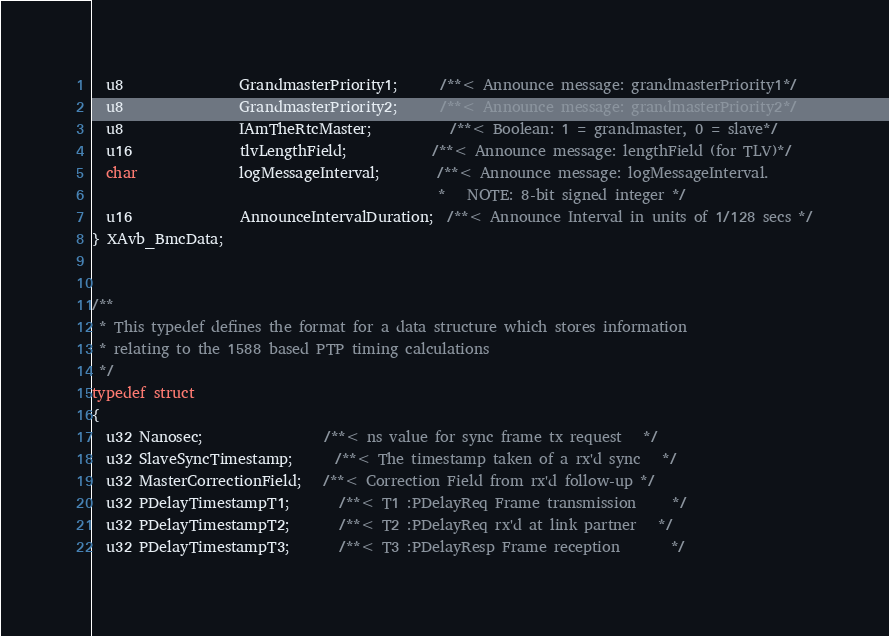Convert code to text. <code><loc_0><loc_0><loc_500><loc_500><_C_>  u8                GrandmasterPriority1;      /**< Announce message: grandmasterPriority1*/
  u8                GrandmasterPriority2;      /**< Announce message: grandmasterPriority2*/
  u8                IAmTheRtcMaster;           /**< Boolean: 1 = grandmaster, 0 = slave*/
  u16               tlvLengthField;            /**< Announce message: lengthField (for TLV)*/
  char              logMessageInterval;        /**< Announce message: logMessageInterval.
                                                *   NOTE: 8-bit signed integer */
  u16               AnnounceIntervalDuration;  /**< Announce Interval in units of 1/128 secs */
} XAvb_BmcData;


/**
 * This typedef defines the format for a data structure which stores information
 * relating to the 1588 based PTP timing calculations
 */
typedef struct
{
  u32 Nanosec;                 /**< ns value for sync frame tx request   */
  u32 SlaveSyncTimestamp;      /**< The timestamp taken of a rx'd sync   */
  u32 MasterCorrectionField;   /**< Correction Field from rx'd follow-up */
  u32 PDelayTimestampT1;       /**< T1 :PDelayReq Frame transmission     */
  u32 PDelayTimestampT2;       /**< T2 :PDelayReq rx'd at link partner   */
  u32 PDelayTimestampT3;       /**< T3 :PDelayResp Frame reception       */</code> 